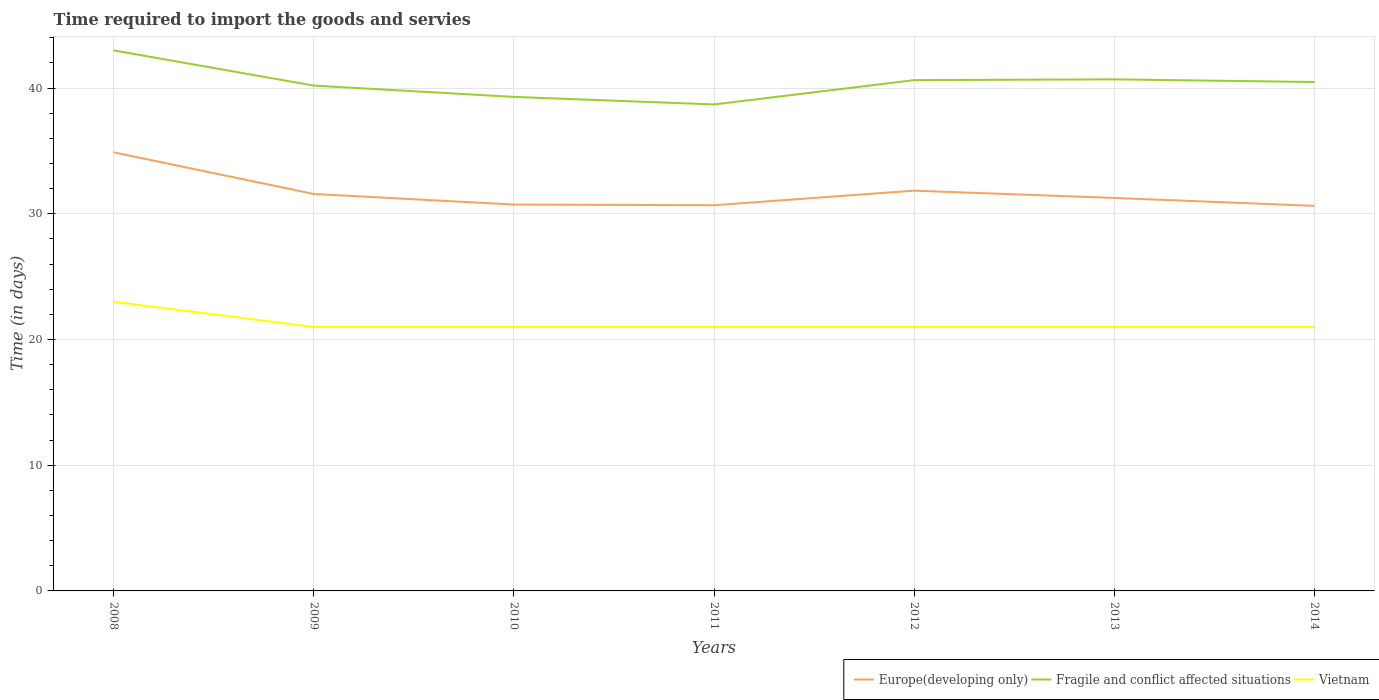Is the number of lines equal to the number of legend labels?
Ensure brevity in your answer.  Yes. Across all years, what is the maximum number of days required to import the goods and services in Europe(developing only)?
Keep it short and to the point. 30.63. In which year was the number of days required to import the goods and services in Fragile and conflict affected situations maximum?
Give a very brief answer. 2011. What is the total number of days required to import the goods and services in Fragile and conflict affected situations in the graph?
Provide a short and direct response. 2.8. What is the difference between the highest and the second highest number of days required to import the goods and services in Europe(developing only)?
Provide a succinct answer. 4.26. What is the difference between the highest and the lowest number of days required to import the goods and services in Fragile and conflict affected situations?
Your answer should be compact. 4. Is the number of days required to import the goods and services in Europe(developing only) strictly greater than the number of days required to import the goods and services in Fragile and conflict affected situations over the years?
Your answer should be compact. Yes. Does the graph contain any zero values?
Make the answer very short. No. Does the graph contain grids?
Ensure brevity in your answer.  Yes. How many legend labels are there?
Provide a succinct answer. 3. What is the title of the graph?
Provide a short and direct response. Time required to import the goods and servies. What is the label or title of the Y-axis?
Your answer should be very brief. Time (in days). What is the Time (in days) in Europe(developing only) in 2008?
Your answer should be very brief. 34.89. What is the Time (in days) of Fragile and conflict affected situations in 2008?
Give a very brief answer. 43. What is the Time (in days) of Vietnam in 2008?
Your answer should be very brief. 23. What is the Time (in days) of Europe(developing only) in 2009?
Provide a succinct answer. 31.58. What is the Time (in days) of Fragile and conflict affected situations in 2009?
Keep it short and to the point. 40.2. What is the Time (in days) in Vietnam in 2009?
Offer a very short reply. 21. What is the Time (in days) in Europe(developing only) in 2010?
Your answer should be very brief. 30.74. What is the Time (in days) of Fragile and conflict affected situations in 2010?
Your answer should be compact. 39.3. What is the Time (in days) of Europe(developing only) in 2011?
Offer a terse response. 30.68. What is the Time (in days) in Fragile and conflict affected situations in 2011?
Your answer should be compact. 38.7. What is the Time (in days) of Vietnam in 2011?
Your answer should be very brief. 21. What is the Time (in days) of Europe(developing only) in 2012?
Your response must be concise. 31.84. What is the Time (in days) in Fragile and conflict affected situations in 2012?
Provide a short and direct response. 40.64. What is the Time (in days) in Europe(developing only) in 2013?
Keep it short and to the point. 31.26. What is the Time (in days) in Fragile and conflict affected situations in 2013?
Give a very brief answer. 40.7. What is the Time (in days) of Europe(developing only) in 2014?
Your answer should be compact. 30.63. What is the Time (in days) in Fragile and conflict affected situations in 2014?
Offer a terse response. 40.48. Across all years, what is the maximum Time (in days) in Europe(developing only)?
Offer a very short reply. 34.89. Across all years, what is the maximum Time (in days) in Fragile and conflict affected situations?
Make the answer very short. 43. Across all years, what is the maximum Time (in days) of Vietnam?
Offer a very short reply. 23. Across all years, what is the minimum Time (in days) of Europe(developing only)?
Offer a terse response. 30.63. Across all years, what is the minimum Time (in days) of Fragile and conflict affected situations?
Make the answer very short. 38.7. What is the total Time (in days) in Europe(developing only) in the graph?
Offer a very short reply. 221.63. What is the total Time (in days) in Fragile and conflict affected situations in the graph?
Your answer should be very brief. 283.02. What is the total Time (in days) in Vietnam in the graph?
Ensure brevity in your answer.  149. What is the difference between the Time (in days) in Europe(developing only) in 2008 and that in 2009?
Your answer should be very brief. 3.31. What is the difference between the Time (in days) of Fragile and conflict affected situations in 2008 and that in 2009?
Keep it short and to the point. 2.8. What is the difference between the Time (in days) in Europe(developing only) in 2008 and that in 2010?
Your answer should be compact. 4.15. What is the difference between the Time (in days) of Vietnam in 2008 and that in 2010?
Your answer should be compact. 2. What is the difference between the Time (in days) of Europe(developing only) in 2008 and that in 2011?
Provide a short and direct response. 4.2. What is the difference between the Time (in days) of Vietnam in 2008 and that in 2011?
Your answer should be very brief. 2. What is the difference between the Time (in days) in Europe(developing only) in 2008 and that in 2012?
Provide a short and direct response. 3.05. What is the difference between the Time (in days) of Fragile and conflict affected situations in 2008 and that in 2012?
Provide a succinct answer. 2.36. What is the difference between the Time (in days) of Europe(developing only) in 2008 and that in 2013?
Provide a succinct answer. 3.63. What is the difference between the Time (in days) of Fragile and conflict affected situations in 2008 and that in 2013?
Provide a short and direct response. 2.3. What is the difference between the Time (in days) in Vietnam in 2008 and that in 2013?
Your response must be concise. 2. What is the difference between the Time (in days) in Europe(developing only) in 2008 and that in 2014?
Give a very brief answer. 4.26. What is the difference between the Time (in days) of Fragile and conflict affected situations in 2008 and that in 2014?
Give a very brief answer. 2.52. What is the difference between the Time (in days) in Vietnam in 2008 and that in 2014?
Give a very brief answer. 2. What is the difference between the Time (in days) in Europe(developing only) in 2009 and that in 2010?
Ensure brevity in your answer.  0.84. What is the difference between the Time (in days) in Europe(developing only) in 2009 and that in 2011?
Make the answer very short. 0.89. What is the difference between the Time (in days) in Europe(developing only) in 2009 and that in 2012?
Offer a terse response. -0.26. What is the difference between the Time (in days) in Fragile and conflict affected situations in 2009 and that in 2012?
Your answer should be very brief. -0.44. What is the difference between the Time (in days) of Europe(developing only) in 2009 and that in 2013?
Your response must be concise. 0.32. What is the difference between the Time (in days) of Fragile and conflict affected situations in 2009 and that in 2013?
Your answer should be compact. -0.5. What is the difference between the Time (in days) in Fragile and conflict affected situations in 2009 and that in 2014?
Give a very brief answer. -0.28. What is the difference between the Time (in days) of Europe(developing only) in 2010 and that in 2011?
Ensure brevity in your answer.  0.05. What is the difference between the Time (in days) of Europe(developing only) in 2010 and that in 2012?
Keep it short and to the point. -1.11. What is the difference between the Time (in days) in Fragile and conflict affected situations in 2010 and that in 2012?
Offer a terse response. -1.34. What is the difference between the Time (in days) in Vietnam in 2010 and that in 2012?
Offer a terse response. 0. What is the difference between the Time (in days) of Europe(developing only) in 2010 and that in 2013?
Provide a short and direct response. -0.53. What is the difference between the Time (in days) of Fragile and conflict affected situations in 2010 and that in 2013?
Your answer should be compact. -1.4. What is the difference between the Time (in days) in Europe(developing only) in 2010 and that in 2014?
Provide a short and direct response. 0.11. What is the difference between the Time (in days) in Fragile and conflict affected situations in 2010 and that in 2014?
Provide a succinct answer. -1.18. What is the difference between the Time (in days) of Europe(developing only) in 2011 and that in 2012?
Your answer should be compact. -1.16. What is the difference between the Time (in days) in Fragile and conflict affected situations in 2011 and that in 2012?
Offer a terse response. -1.94. What is the difference between the Time (in days) of Europe(developing only) in 2011 and that in 2013?
Offer a very short reply. -0.58. What is the difference between the Time (in days) in Fragile and conflict affected situations in 2011 and that in 2013?
Ensure brevity in your answer.  -2. What is the difference between the Time (in days) of Vietnam in 2011 and that in 2013?
Offer a very short reply. 0. What is the difference between the Time (in days) in Europe(developing only) in 2011 and that in 2014?
Your response must be concise. 0.05. What is the difference between the Time (in days) of Fragile and conflict affected situations in 2011 and that in 2014?
Make the answer very short. -1.78. What is the difference between the Time (in days) of Europe(developing only) in 2012 and that in 2013?
Provide a short and direct response. 0.58. What is the difference between the Time (in days) of Fragile and conflict affected situations in 2012 and that in 2013?
Provide a succinct answer. -0.06. What is the difference between the Time (in days) in Europe(developing only) in 2012 and that in 2014?
Keep it short and to the point. 1.21. What is the difference between the Time (in days) in Fragile and conflict affected situations in 2012 and that in 2014?
Your answer should be very brief. 0.15. What is the difference between the Time (in days) in Europe(developing only) in 2013 and that in 2014?
Provide a short and direct response. 0.63. What is the difference between the Time (in days) in Fragile and conflict affected situations in 2013 and that in 2014?
Keep it short and to the point. 0.21. What is the difference between the Time (in days) of Europe(developing only) in 2008 and the Time (in days) of Fragile and conflict affected situations in 2009?
Provide a succinct answer. -5.31. What is the difference between the Time (in days) of Europe(developing only) in 2008 and the Time (in days) of Vietnam in 2009?
Your response must be concise. 13.89. What is the difference between the Time (in days) of Fragile and conflict affected situations in 2008 and the Time (in days) of Vietnam in 2009?
Keep it short and to the point. 22. What is the difference between the Time (in days) in Europe(developing only) in 2008 and the Time (in days) in Fragile and conflict affected situations in 2010?
Provide a short and direct response. -4.41. What is the difference between the Time (in days) of Europe(developing only) in 2008 and the Time (in days) of Vietnam in 2010?
Provide a short and direct response. 13.89. What is the difference between the Time (in days) in Europe(developing only) in 2008 and the Time (in days) in Fragile and conflict affected situations in 2011?
Provide a short and direct response. -3.81. What is the difference between the Time (in days) of Europe(developing only) in 2008 and the Time (in days) of Vietnam in 2011?
Provide a short and direct response. 13.89. What is the difference between the Time (in days) in Fragile and conflict affected situations in 2008 and the Time (in days) in Vietnam in 2011?
Your response must be concise. 22. What is the difference between the Time (in days) in Europe(developing only) in 2008 and the Time (in days) in Fragile and conflict affected situations in 2012?
Your response must be concise. -5.75. What is the difference between the Time (in days) of Europe(developing only) in 2008 and the Time (in days) of Vietnam in 2012?
Give a very brief answer. 13.89. What is the difference between the Time (in days) of Fragile and conflict affected situations in 2008 and the Time (in days) of Vietnam in 2012?
Offer a terse response. 22. What is the difference between the Time (in days) of Europe(developing only) in 2008 and the Time (in days) of Fragile and conflict affected situations in 2013?
Make the answer very short. -5.81. What is the difference between the Time (in days) of Europe(developing only) in 2008 and the Time (in days) of Vietnam in 2013?
Offer a terse response. 13.89. What is the difference between the Time (in days) in Fragile and conflict affected situations in 2008 and the Time (in days) in Vietnam in 2013?
Your answer should be compact. 22. What is the difference between the Time (in days) of Europe(developing only) in 2008 and the Time (in days) of Fragile and conflict affected situations in 2014?
Offer a terse response. -5.6. What is the difference between the Time (in days) in Europe(developing only) in 2008 and the Time (in days) in Vietnam in 2014?
Provide a succinct answer. 13.89. What is the difference between the Time (in days) in Fragile and conflict affected situations in 2008 and the Time (in days) in Vietnam in 2014?
Your answer should be very brief. 22. What is the difference between the Time (in days) of Europe(developing only) in 2009 and the Time (in days) of Fragile and conflict affected situations in 2010?
Your answer should be very brief. -7.72. What is the difference between the Time (in days) of Europe(developing only) in 2009 and the Time (in days) of Vietnam in 2010?
Keep it short and to the point. 10.58. What is the difference between the Time (in days) of Fragile and conflict affected situations in 2009 and the Time (in days) of Vietnam in 2010?
Keep it short and to the point. 19.2. What is the difference between the Time (in days) in Europe(developing only) in 2009 and the Time (in days) in Fragile and conflict affected situations in 2011?
Offer a terse response. -7.12. What is the difference between the Time (in days) of Europe(developing only) in 2009 and the Time (in days) of Vietnam in 2011?
Keep it short and to the point. 10.58. What is the difference between the Time (in days) of Fragile and conflict affected situations in 2009 and the Time (in days) of Vietnam in 2011?
Your answer should be compact. 19.2. What is the difference between the Time (in days) in Europe(developing only) in 2009 and the Time (in days) in Fragile and conflict affected situations in 2012?
Give a very brief answer. -9.06. What is the difference between the Time (in days) of Europe(developing only) in 2009 and the Time (in days) of Vietnam in 2012?
Offer a very short reply. 10.58. What is the difference between the Time (in days) in Europe(developing only) in 2009 and the Time (in days) in Fragile and conflict affected situations in 2013?
Your answer should be very brief. -9.12. What is the difference between the Time (in days) of Europe(developing only) in 2009 and the Time (in days) of Vietnam in 2013?
Provide a succinct answer. 10.58. What is the difference between the Time (in days) of Fragile and conflict affected situations in 2009 and the Time (in days) of Vietnam in 2013?
Provide a short and direct response. 19.2. What is the difference between the Time (in days) of Europe(developing only) in 2009 and the Time (in days) of Fragile and conflict affected situations in 2014?
Your answer should be very brief. -8.91. What is the difference between the Time (in days) in Europe(developing only) in 2009 and the Time (in days) in Vietnam in 2014?
Provide a succinct answer. 10.58. What is the difference between the Time (in days) in Europe(developing only) in 2010 and the Time (in days) in Fragile and conflict affected situations in 2011?
Give a very brief answer. -7.96. What is the difference between the Time (in days) in Europe(developing only) in 2010 and the Time (in days) in Vietnam in 2011?
Offer a terse response. 9.74. What is the difference between the Time (in days) in Fragile and conflict affected situations in 2010 and the Time (in days) in Vietnam in 2011?
Your answer should be compact. 18.3. What is the difference between the Time (in days) of Europe(developing only) in 2010 and the Time (in days) of Fragile and conflict affected situations in 2012?
Provide a short and direct response. -9.9. What is the difference between the Time (in days) of Europe(developing only) in 2010 and the Time (in days) of Vietnam in 2012?
Make the answer very short. 9.74. What is the difference between the Time (in days) in Europe(developing only) in 2010 and the Time (in days) in Fragile and conflict affected situations in 2013?
Offer a terse response. -9.96. What is the difference between the Time (in days) of Europe(developing only) in 2010 and the Time (in days) of Vietnam in 2013?
Provide a succinct answer. 9.74. What is the difference between the Time (in days) of Fragile and conflict affected situations in 2010 and the Time (in days) of Vietnam in 2013?
Your response must be concise. 18.3. What is the difference between the Time (in days) of Europe(developing only) in 2010 and the Time (in days) of Fragile and conflict affected situations in 2014?
Offer a terse response. -9.75. What is the difference between the Time (in days) of Europe(developing only) in 2010 and the Time (in days) of Vietnam in 2014?
Give a very brief answer. 9.74. What is the difference between the Time (in days) in Fragile and conflict affected situations in 2010 and the Time (in days) in Vietnam in 2014?
Offer a terse response. 18.3. What is the difference between the Time (in days) in Europe(developing only) in 2011 and the Time (in days) in Fragile and conflict affected situations in 2012?
Keep it short and to the point. -9.95. What is the difference between the Time (in days) in Europe(developing only) in 2011 and the Time (in days) in Vietnam in 2012?
Your answer should be very brief. 9.68. What is the difference between the Time (in days) of Europe(developing only) in 2011 and the Time (in days) of Fragile and conflict affected situations in 2013?
Give a very brief answer. -10.01. What is the difference between the Time (in days) in Europe(developing only) in 2011 and the Time (in days) in Vietnam in 2013?
Give a very brief answer. 9.68. What is the difference between the Time (in days) in Europe(developing only) in 2011 and the Time (in days) in Fragile and conflict affected situations in 2014?
Your response must be concise. -9.8. What is the difference between the Time (in days) of Europe(developing only) in 2011 and the Time (in days) of Vietnam in 2014?
Your answer should be compact. 9.68. What is the difference between the Time (in days) in Europe(developing only) in 2012 and the Time (in days) in Fragile and conflict affected situations in 2013?
Keep it short and to the point. -8.85. What is the difference between the Time (in days) in Europe(developing only) in 2012 and the Time (in days) in Vietnam in 2013?
Your answer should be very brief. 10.84. What is the difference between the Time (in days) in Fragile and conflict affected situations in 2012 and the Time (in days) in Vietnam in 2013?
Keep it short and to the point. 19.64. What is the difference between the Time (in days) in Europe(developing only) in 2012 and the Time (in days) in Fragile and conflict affected situations in 2014?
Provide a succinct answer. -8.64. What is the difference between the Time (in days) of Europe(developing only) in 2012 and the Time (in days) of Vietnam in 2014?
Ensure brevity in your answer.  10.84. What is the difference between the Time (in days) in Fragile and conflict affected situations in 2012 and the Time (in days) in Vietnam in 2014?
Give a very brief answer. 19.64. What is the difference between the Time (in days) in Europe(developing only) in 2013 and the Time (in days) in Fragile and conflict affected situations in 2014?
Give a very brief answer. -9.22. What is the difference between the Time (in days) of Europe(developing only) in 2013 and the Time (in days) of Vietnam in 2014?
Offer a very short reply. 10.26. What is the difference between the Time (in days) in Fragile and conflict affected situations in 2013 and the Time (in days) in Vietnam in 2014?
Your answer should be very brief. 19.7. What is the average Time (in days) in Europe(developing only) per year?
Give a very brief answer. 31.66. What is the average Time (in days) in Fragile and conflict affected situations per year?
Your answer should be compact. 40.43. What is the average Time (in days) of Vietnam per year?
Provide a short and direct response. 21.29. In the year 2008, what is the difference between the Time (in days) in Europe(developing only) and Time (in days) in Fragile and conflict affected situations?
Your response must be concise. -8.11. In the year 2008, what is the difference between the Time (in days) of Europe(developing only) and Time (in days) of Vietnam?
Keep it short and to the point. 11.89. In the year 2008, what is the difference between the Time (in days) in Fragile and conflict affected situations and Time (in days) in Vietnam?
Your answer should be compact. 20. In the year 2009, what is the difference between the Time (in days) of Europe(developing only) and Time (in days) of Fragile and conflict affected situations?
Ensure brevity in your answer.  -8.62. In the year 2009, what is the difference between the Time (in days) of Europe(developing only) and Time (in days) of Vietnam?
Your response must be concise. 10.58. In the year 2009, what is the difference between the Time (in days) in Fragile and conflict affected situations and Time (in days) in Vietnam?
Offer a very short reply. 19.2. In the year 2010, what is the difference between the Time (in days) of Europe(developing only) and Time (in days) of Fragile and conflict affected situations?
Offer a very short reply. -8.56. In the year 2010, what is the difference between the Time (in days) in Europe(developing only) and Time (in days) in Vietnam?
Your answer should be compact. 9.74. In the year 2011, what is the difference between the Time (in days) in Europe(developing only) and Time (in days) in Fragile and conflict affected situations?
Keep it short and to the point. -8.02. In the year 2011, what is the difference between the Time (in days) of Europe(developing only) and Time (in days) of Vietnam?
Ensure brevity in your answer.  9.68. In the year 2012, what is the difference between the Time (in days) of Europe(developing only) and Time (in days) of Fragile and conflict affected situations?
Ensure brevity in your answer.  -8.79. In the year 2012, what is the difference between the Time (in days) in Europe(developing only) and Time (in days) in Vietnam?
Offer a terse response. 10.84. In the year 2012, what is the difference between the Time (in days) in Fragile and conflict affected situations and Time (in days) in Vietnam?
Offer a very short reply. 19.64. In the year 2013, what is the difference between the Time (in days) of Europe(developing only) and Time (in days) of Fragile and conflict affected situations?
Your answer should be very brief. -9.43. In the year 2013, what is the difference between the Time (in days) in Europe(developing only) and Time (in days) in Vietnam?
Your answer should be compact. 10.26. In the year 2013, what is the difference between the Time (in days) in Fragile and conflict affected situations and Time (in days) in Vietnam?
Your response must be concise. 19.7. In the year 2014, what is the difference between the Time (in days) in Europe(developing only) and Time (in days) in Fragile and conflict affected situations?
Your answer should be very brief. -9.85. In the year 2014, what is the difference between the Time (in days) of Europe(developing only) and Time (in days) of Vietnam?
Provide a succinct answer. 9.63. In the year 2014, what is the difference between the Time (in days) in Fragile and conflict affected situations and Time (in days) in Vietnam?
Your answer should be compact. 19.48. What is the ratio of the Time (in days) of Europe(developing only) in 2008 to that in 2009?
Provide a short and direct response. 1.1. What is the ratio of the Time (in days) in Fragile and conflict affected situations in 2008 to that in 2009?
Offer a terse response. 1.07. What is the ratio of the Time (in days) in Vietnam in 2008 to that in 2009?
Provide a short and direct response. 1.1. What is the ratio of the Time (in days) in Europe(developing only) in 2008 to that in 2010?
Provide a short and direct response. 1.14. What is the ratio of the Time (in days) in Fragile and conflict affected situations in 2008 to that in 2010?
Give a very brief answer. 1.09. What is the ratio of the Time (in days) in Vietnam in 2008 to that in 2010?
Ensure brevity in your answer.  1.1. What is the ratio of the Time (in days) in Europe(developing only) in 2008 to that in 2011?
Offer a terse response. 1.14. What is the ratio of the Time (in days) of Vietnam in 2008 to that in 2011?
Offer a very short reply. 1.1. What is the ratio of the Time (in days) in Europe(developing only) in 2008 to that in 2012?
Give a very brief answer. 1.1. What is the ratio of the Time (in days) of Fragile and conflict affected situations in 2008 to that in 2012?
Offer a terse response. 1.06. What is the ratio of the Time (in days) in Vietnam in 2008 to that in 2012?
Provide a succinct answer. 1.1. What is the ratio of the Time (in days) in Europe(developing only) in 2008 to that in 2013?
Your answer should be compact. 1.12. What is the ratio of the Time (in days) in Fragile and conflict affected situations in 2008 to that in 2013?
Keep it short and to the point. 1.06. What is the ratio of the Time (in days) of Vietnam in 2008 to that in 2013?
Offer a very short reply. 1.1. What is the ratio of the Time (in days) of Europe(developing only) in 2008 to that in 2014?
Provide a short and direct response. 1.14. What is the ratio of the Time (in days) in Fragile and conflict affected situations in 2008 to that in 2014?
Ensure brevity in your answer.  1.06. What is the ratio of the Time (in days) in Vietnam in 2008 to that in 2014?
Your response must be concise. 1.1. What is the ratio of the Time (in days) of Europe(developing only) in 2009 to that in 2010?
Your response must be concise. 1.03. What is the ratio of the Time (in days) in Fragile and conflict affected situations in 2009 to that in 2010?
Give a very brief answer. 1.02. What is the ratio of the Time (in days) of Europe(developing only) in 2009 to that in 2011?
Keep it short and to the point. 1.03. What is the ratio of the Time (in days) in Fragile and conflict affected situations in 2009 to that in 2011?
Your answer should be very brief. 1.04. What is the ratio of the Time (in days) in Vietnam in 2009 to that in 2011?
Your response must be concise. 1. What is the ratio of the Time (in days) in Fragile and conflict affected situations in 2009 to that in 2012?
Keep it short and to the point. 0.99. What is the ratio of the Time (in days) of Vietnam in 2009 to that in 2012?
Give a very brief answer. 1. What is the ratio of the Time (in days) of Europe(developing only) in 2009 to that in 2013?
Keep it short and to the point. 1.01. What is the ratio of the Time (in days) of Fragile and conflict affected situations in 2009 to that in 2013?
Provide a succinct answer. 0.99. What is the ratio of the Time (in days) in Vietnam in 2009 to that in 2013?
Your response must be concise. 1. What is the ratio of the Time (in days) in Europe(developing only) in 2009 to that in 2014?
Give a very brief answer. 1.03. What is the ratio of the Time (in days) in Fragile and conflict affected situations in 2009 to that in 2014?
Make the answer very short. 0.99. What is the ratio of the Time (in days) of Vietnam in 2009 to that in 2014?
Ensure brevity in your answer.  1. What is the ratio of the Time (in days) of Europe(developing only) in 2010 to that in 2011?
Give a very brief answer. 1. What is the ratio of the Time (in days) of Fragile and conflict affected situations in 2010 to that in 2011?
Offer a terse response. 1.02. What is the ratio of the Time (in days) of Europe(developing only) in 2010 to that in 2012?
Your answer should be compact. 0.97. What is the ratio of the Time (in days) of Fragile and conflict affected situations in 2010 to that in 2012?
Keep it short and to the point. 0.97. What is the ratio of the Time (in days) in Vietnam in 2010 to that in 2012?
Offer a very short reply. 1. What is the ratio of the Time (in days) of Europe(developing only) in 2010 to that in 2013?
Your answer should be very brief. 0.98. What is the ratio of the Time (in days) in Fragile and conflict affected situations in 2010 to that in 2013?
Offer a very short reply. 0.97. What is the ratio of the Time (in days) of Vietnam in 2010 to that in 2013?
Offer a terse response. 1. What is the ratio of the Time (in days) of Fragile and conflict affected situations in 2010 to that in 2014?
Make the answer very short. 0.97. What is the ratio of the Time (in days) of Vietnam in 2010 to that in 2014?
Make the answer very short. 1. What is the ratio of the Time (in days) in Europe(developing only) in 2011 to that in 2012?
Ensure brevity in your answer.  0.96. What is the ratio of the Time (in days) of Fragile and conflict affected situations in 2011 to that in 2012?
Make the answer very short. 0.95. What is the ratio of the Time (in days) of Vietnam in 2011 to that in 2012?
Keep it short and to the point. 1. What is the ratio of the Time (in days) of Europe(developing only) in 2011 to that in 2013?
Ensure brevity in your answer.  0.98. What is the ratio of the Time (in days) of Fragile and conflict affected situations in 2011 to that in 2013?
Make the answer very short. 0.95. What is the ratio of the Time (in days) in Vietnam in 2011 to that in 2013?
Make the answer very short. 1. What is the ratio of the Time (in days) of Europe(developing only) in 2011 to that in 2014?
Provide a short and direct response. 1. What is the ratio of the Time (in days) in Fragile and conflict affected situations in 2011 to that in 2014?
Offer a very short reply. 0.96. What is the ratio of the Time (in days) of Vietnam in 2011 to that in 2014?
Offer a terse response. 1. What is the ratio of the Time (in days) of Europe(developing only) in 2012 to that in 2013?
Ensure brevity in your answer.  1.02. What is the ratio of the Time (in days) of Vietnam in 2012 to that in 2013?
Ensure brevity in your answer.  1. What is the ratio of the Time (in days) in Europe(developing only) in 2012 to that in 2014?
Your answer should be compact. 1.04. What is the ratio of the Time (in days) in Fragile and conflict affected situations in 2012 to that in 2014?
Offer a terse response. 1. What is the ratio of the Time (in days) in Europe(developing only) in 2013 to that in 2014?
Give a very brief answer. 1.02. What is the ratio of the Time (in days) in Vietnam in 2013 to that in 2014?
Make the answer very short. 1. What is the difference between the highest and the second highest Time (in days) of Europe(developing only)?
Your answer should be very brief. 3.05. What is the difference between the highest and the second highest Time (in days) of Fragile and conflict affected situations?
Your response must be concise. 2.3. What is the difference between the highest and the lowest Time (in days) in Europe(developing only)?
Provide a succinct answer. 4.26. What is the difference between the highest and the lowest Time (in days) in Vietnam?
Give a very brief answer. 2. 